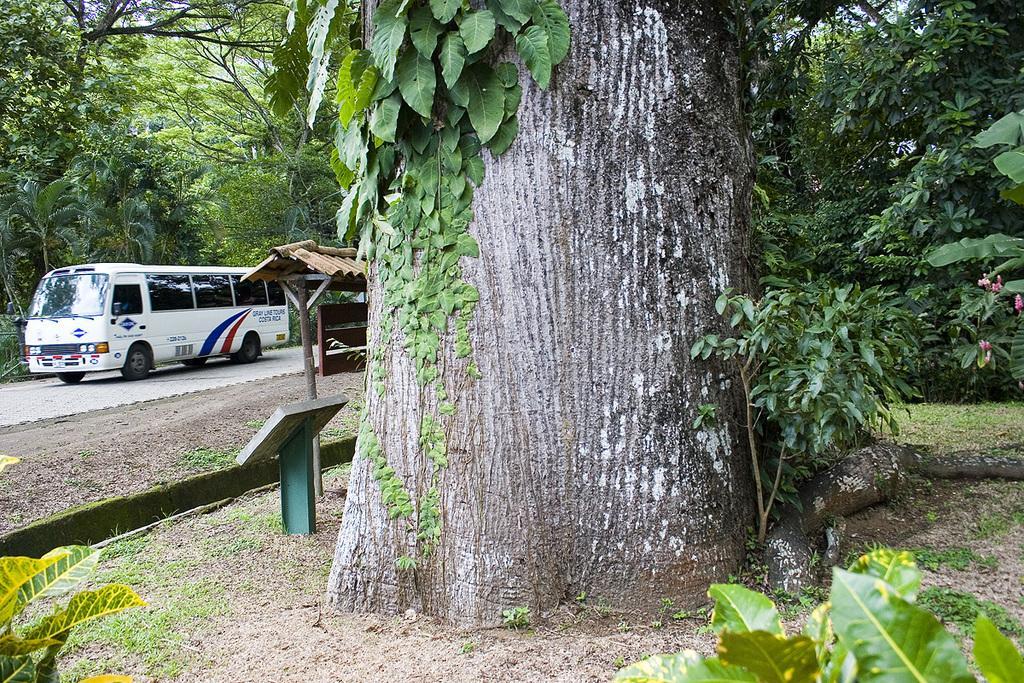Could you give a brief overview of what you see in this image? In this image, we can see a bus on the road and in the background, there are trees and we can see a shed and boards and plants. 